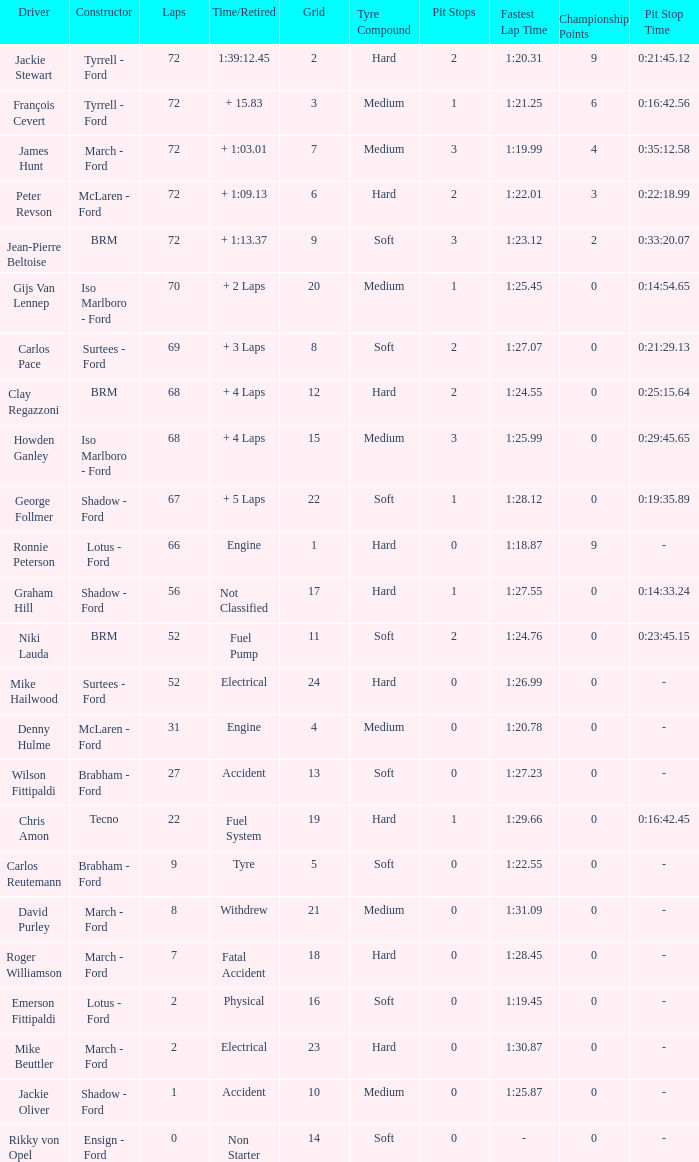What is the top grid that laps less than 66 and a retried engine? 4.0. 